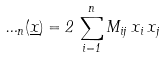<formula> <loc_0><loc_0><loc_500><loc_500>\Phi _ { n } ( \underline { x } ) = 2 \, \sum _ { i = 1 } ^ { n } M _ { i j } \, x _ { i } \, x _ { j }</formula> 